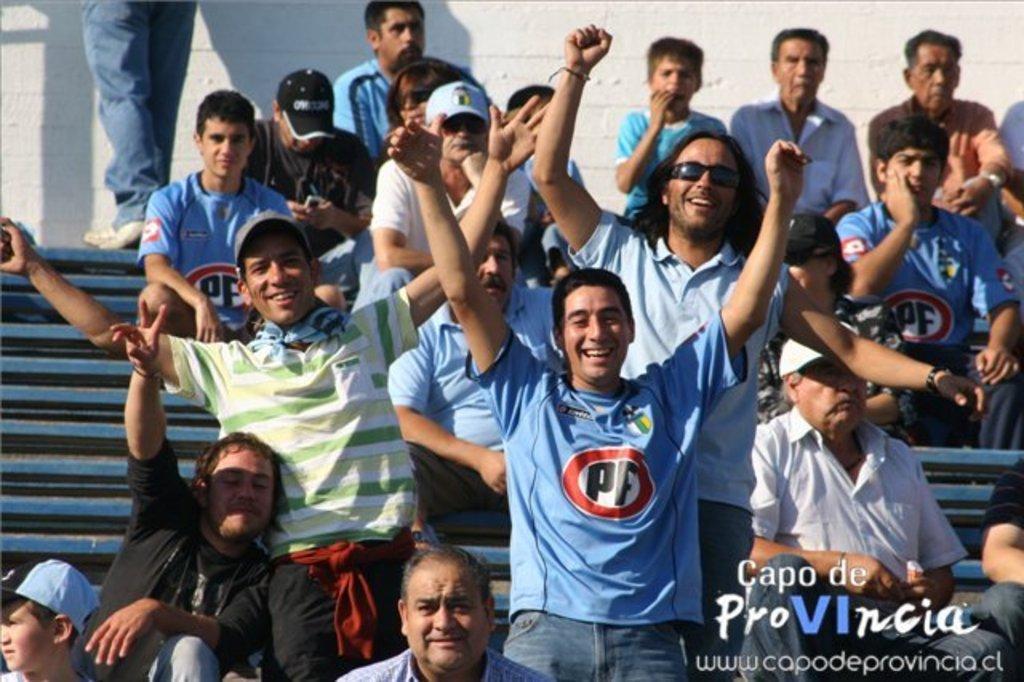How would you summarize this image in a sentence or two? In this image there are few people sitting on steps and few are standing, in the background there is a wall, on the bottom right there is text. 